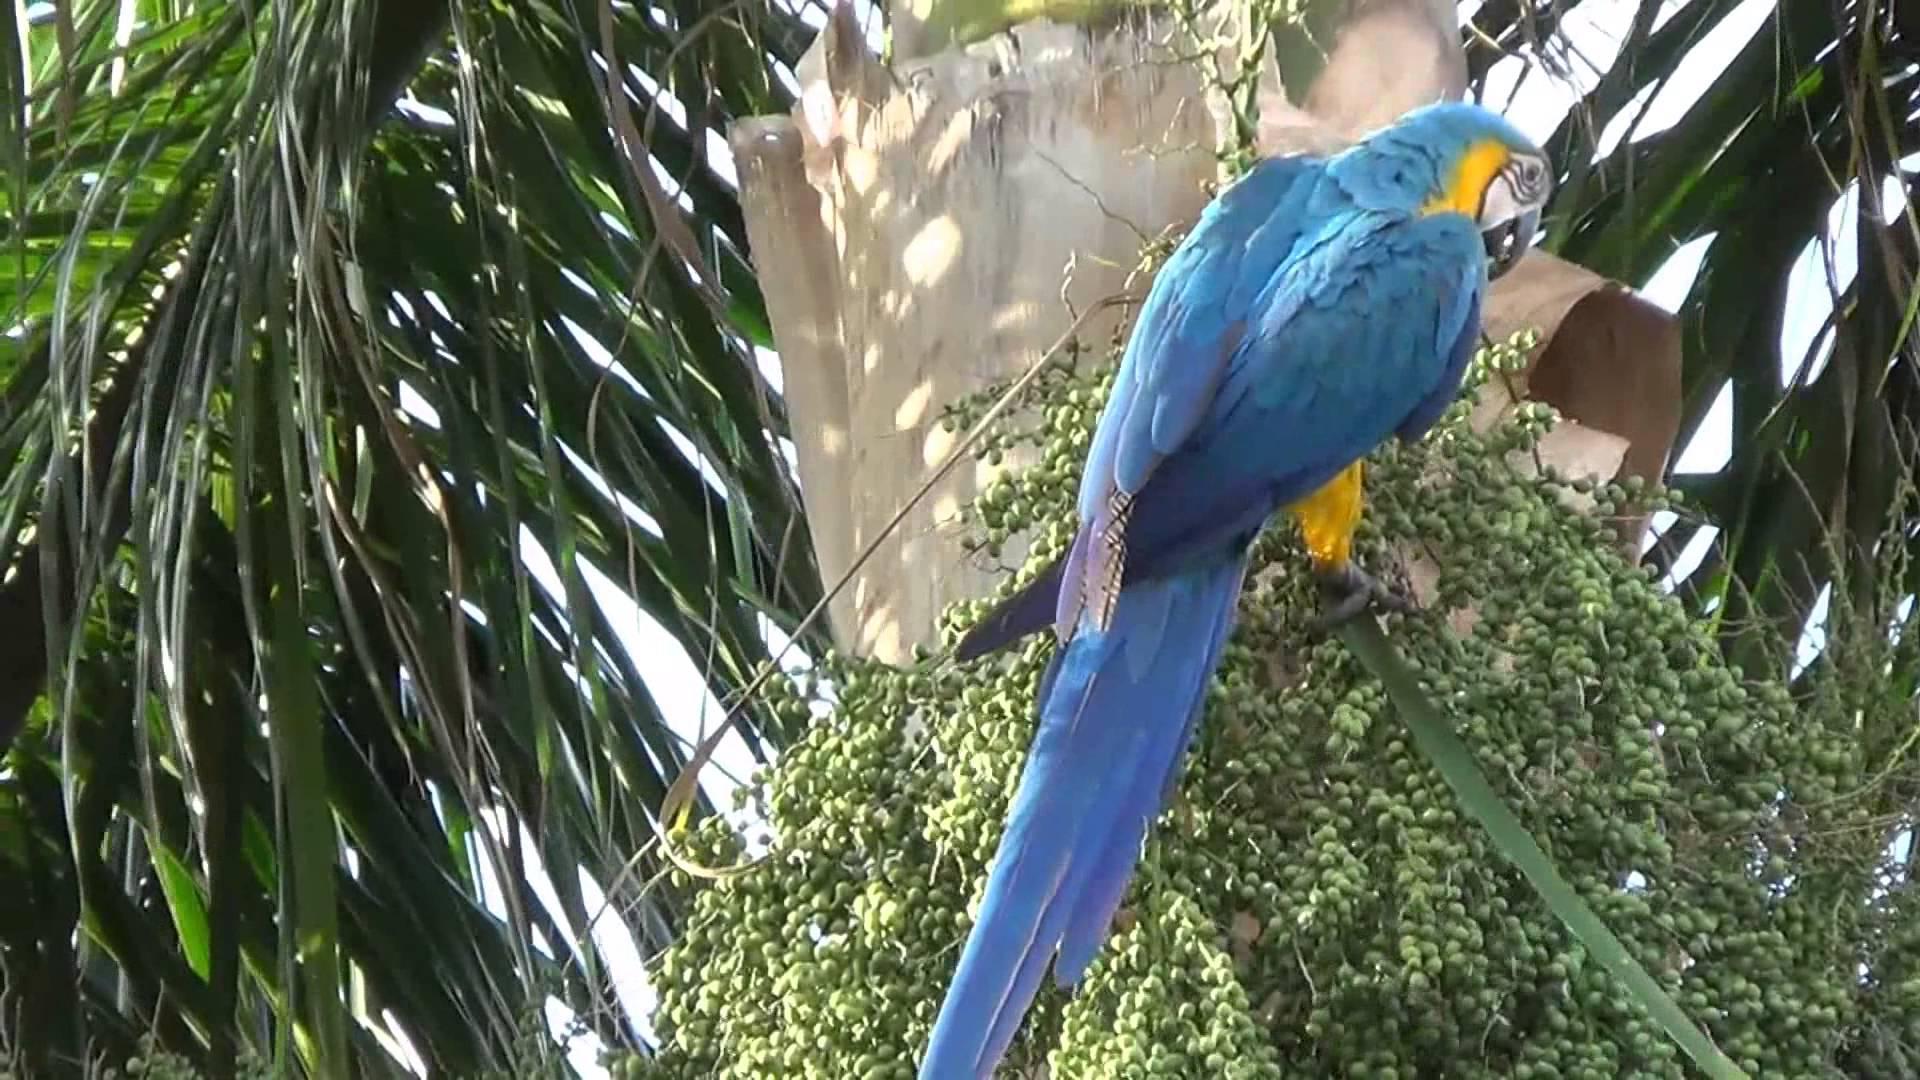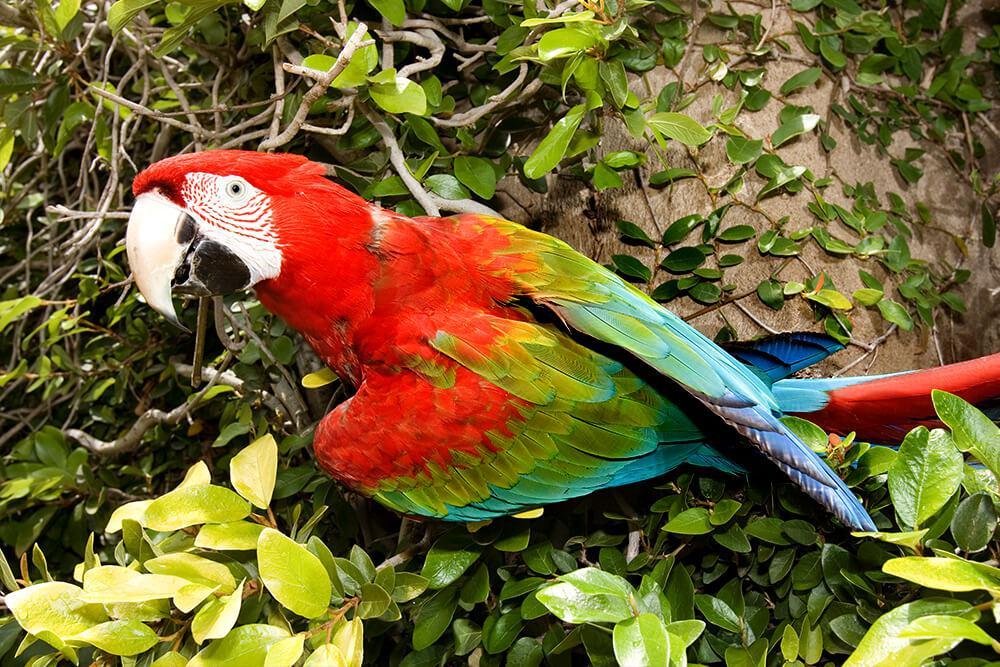The first image is the image on the left, the second image is the image on the right. Given the left and right images, does the statement "There are two parrots." hold true? Answer yes or no. Yes. The first image is the image on the left, the second image is the image on the right. Analyze the images presented: Is the assertion "There are exactly two birds in total." valid? Answer yes or no. Yes. 